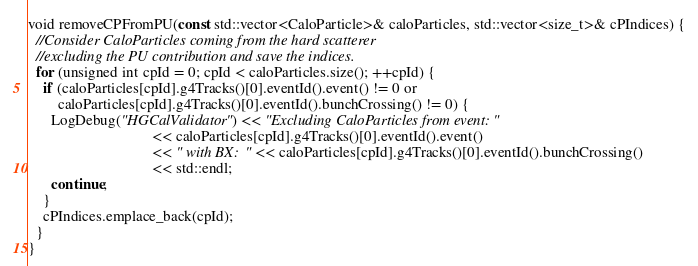<code> <loc_0><loc_0><loc_500><loc_500><_C_>void removeCPFromPU(const std::vector<CaloParticle>& caloParticles, std::vector<size_t>& cPIndices) {
  //Consider CaloParticles coming from the hard scatterer
  //excluding the PU contribution and save the indices.
  for (unsigned int cpId = 0; cpId < caloParticles.size(); ++cpId) {
    if (caloParticles[cpId].g4Tracks()[0].eventId().event() != 0 or
        caloParticles[cpId].g4Tracks()[0].eventId().bunchCrossing() != 0) {
      LogDebug("HGCalValidator") << "Excluding CaloParticles from event: "
                                 << caloParticles[cpId].g4Tracks()[0].eventId().event()
                                 << " with BX: " << caloParticles[cpId].g4Tracks()[0].eventId().bunchCrossing()
                                 << std::endl;
      continue;
    }
    cPIndices.emplace_back(cpId);
  }
}
</code> 